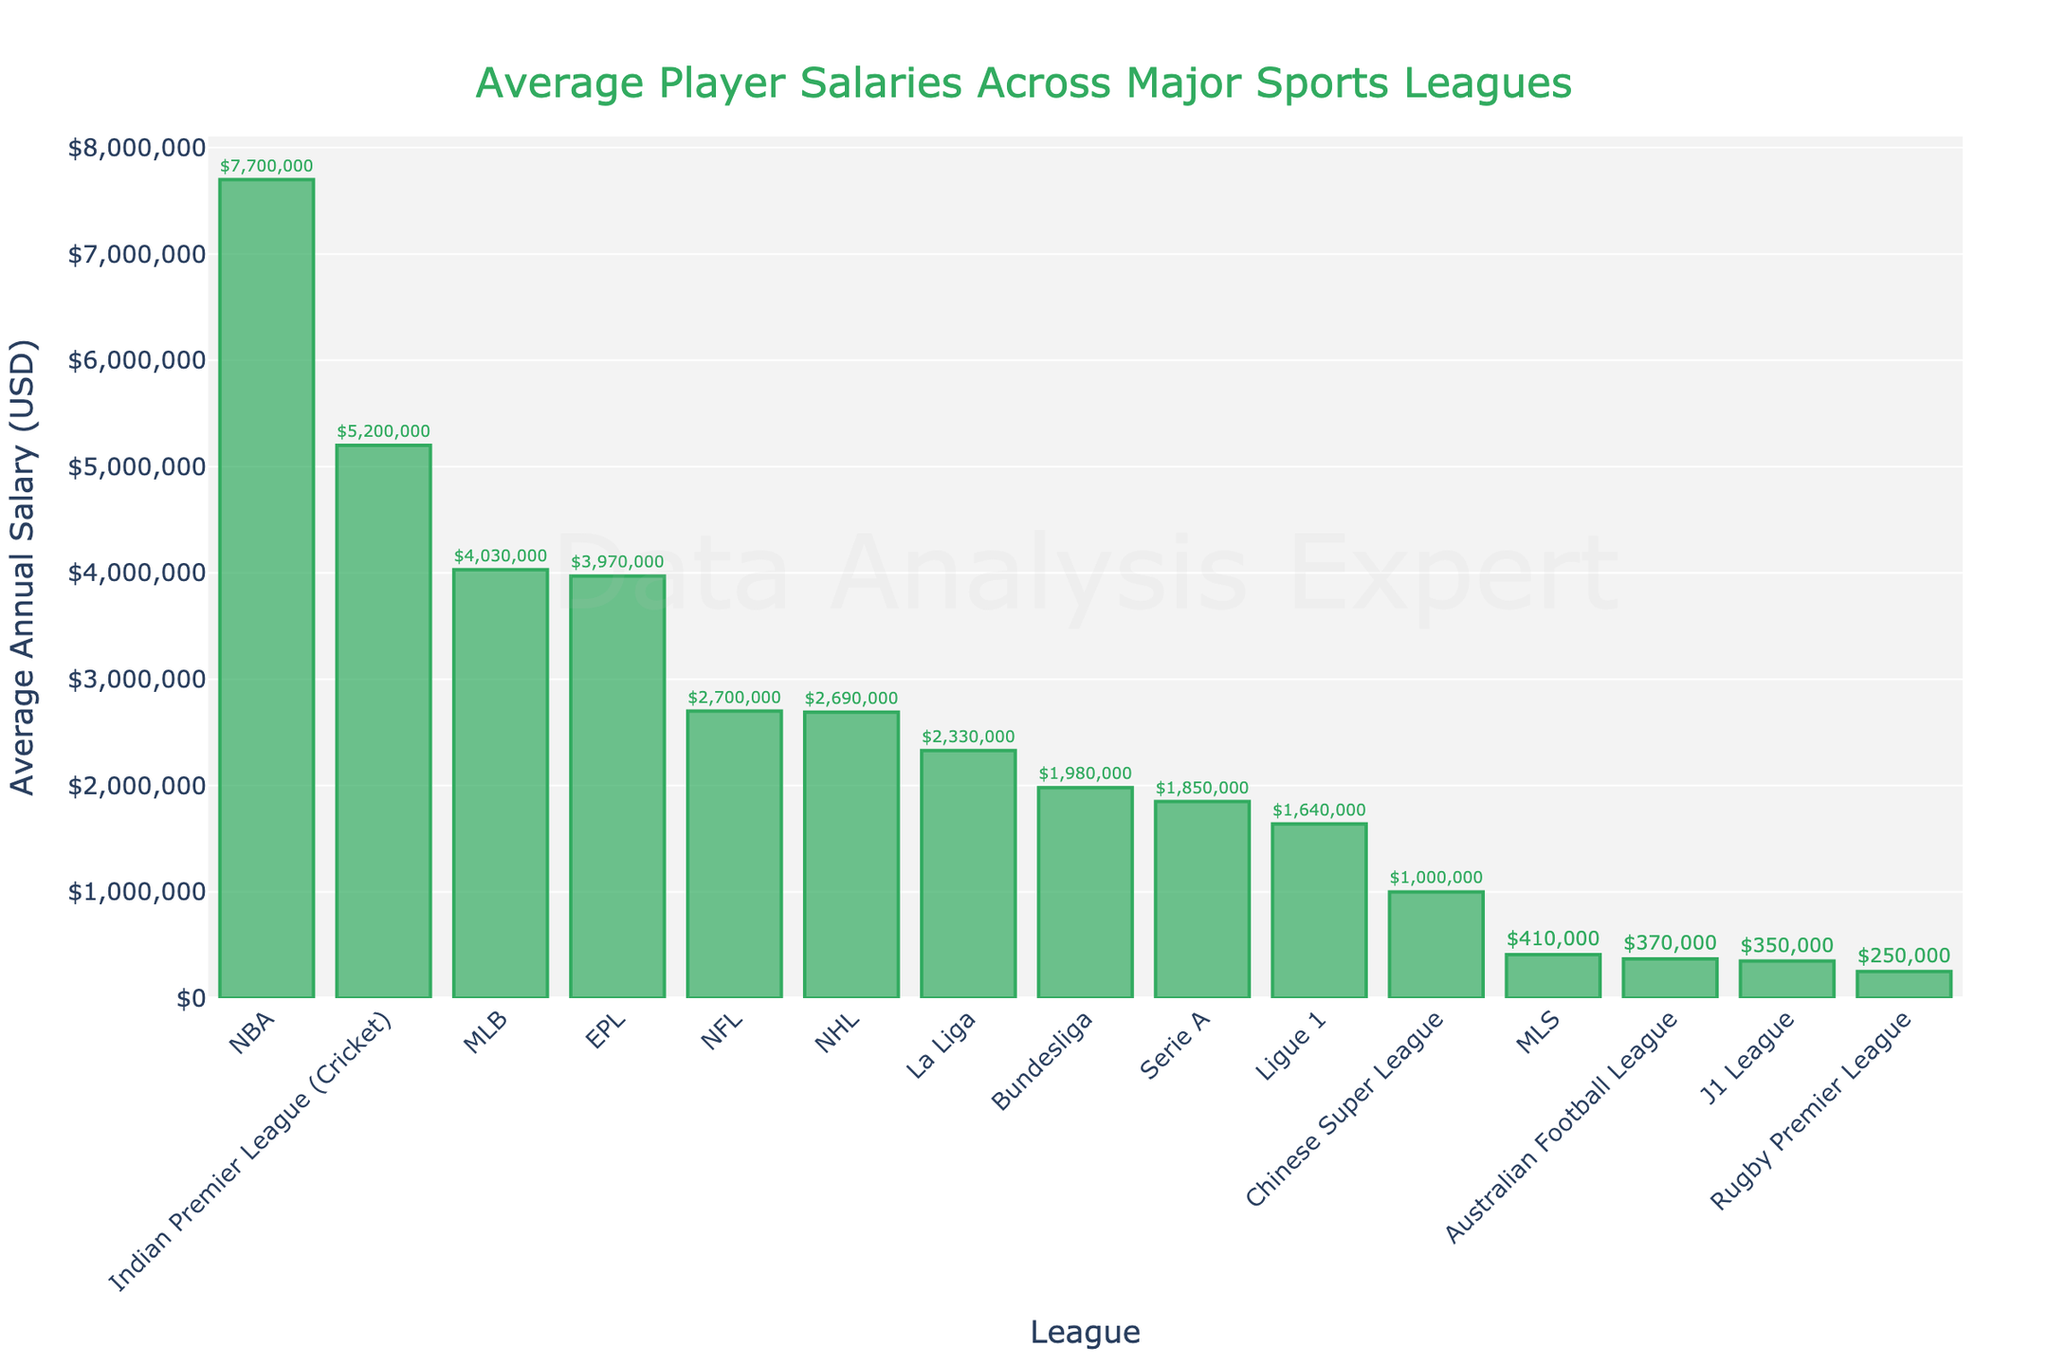What is the league with the highest average annual salary? The highest bar on the chart represents the NBA, indicating that it has the highest average annual salary
Answer: NBA Which league has a higher average annual salary, MLS or J1 League? By comparing the heights of the bars for MLS and J1 League, we see that the J1 League bar is higher than the MLS bar
Answer: J1 League How much more does an average NBA player make compared to an NFL player? Look at the heights of the bars for NBA and NFL, then subtract the NFL average salary from the NBA average salary: $7,700,000 - $2,700,000 = $5,000,000
Answer: $5,000,000 What is the average salary of players in the Bundesliga compared to Ligue 1? Compare the heights of the Bundesliga and Ligue 1 bars, seeing that Bundesliga's bar is taller, indicating a higher average salary: $1,980,000 - $1,640,000 = $340,000
Answer: $340,000 Which two leagues have the closest average annual salaries? By examining the heights of the bars, we see the closest bars are for EPL and MLB, with EPL at $3,970,000 and MLB at $4,030,000. The difference is only $60,000
Answer: EPL and MLB How does the average salary of an Indian Premier League (Cricket) player compare to a Major League Soccer player? Compare the heights of the bars for Indian Premier League and MLS, noting that the Indian Premier League bar is significantly taller: $5,200,000 vs. $410,000
Answer: Indian Premier League (Cricket) is much higher Which league has the lowest average annual salary? Look at the shortest bar on the chart; it corresponds to the Rugby Premier League
Answer: Rugby Premier League How much higher is the average salary in the NBA compared to the Bundesliga and Serie A combined? Add the average salaries of Bundesliga ($1,980,000) and Serie A ($1,850,000), then subtract the sum from the NBA salary: $7,700,000 - ($1,980,000 + $1,850,000) = $3,870,000
Answer: $3,870,000 Which leagues have average salaries greater than $2,000,000? By viewing the bars above the $2,000,000 mark, the leagues are NBA, NFL, MLB, NHL, EPL, and Indian Premier League
Answer: NBA, NFL, MLB, NHL, EPL, Indian Premier League 